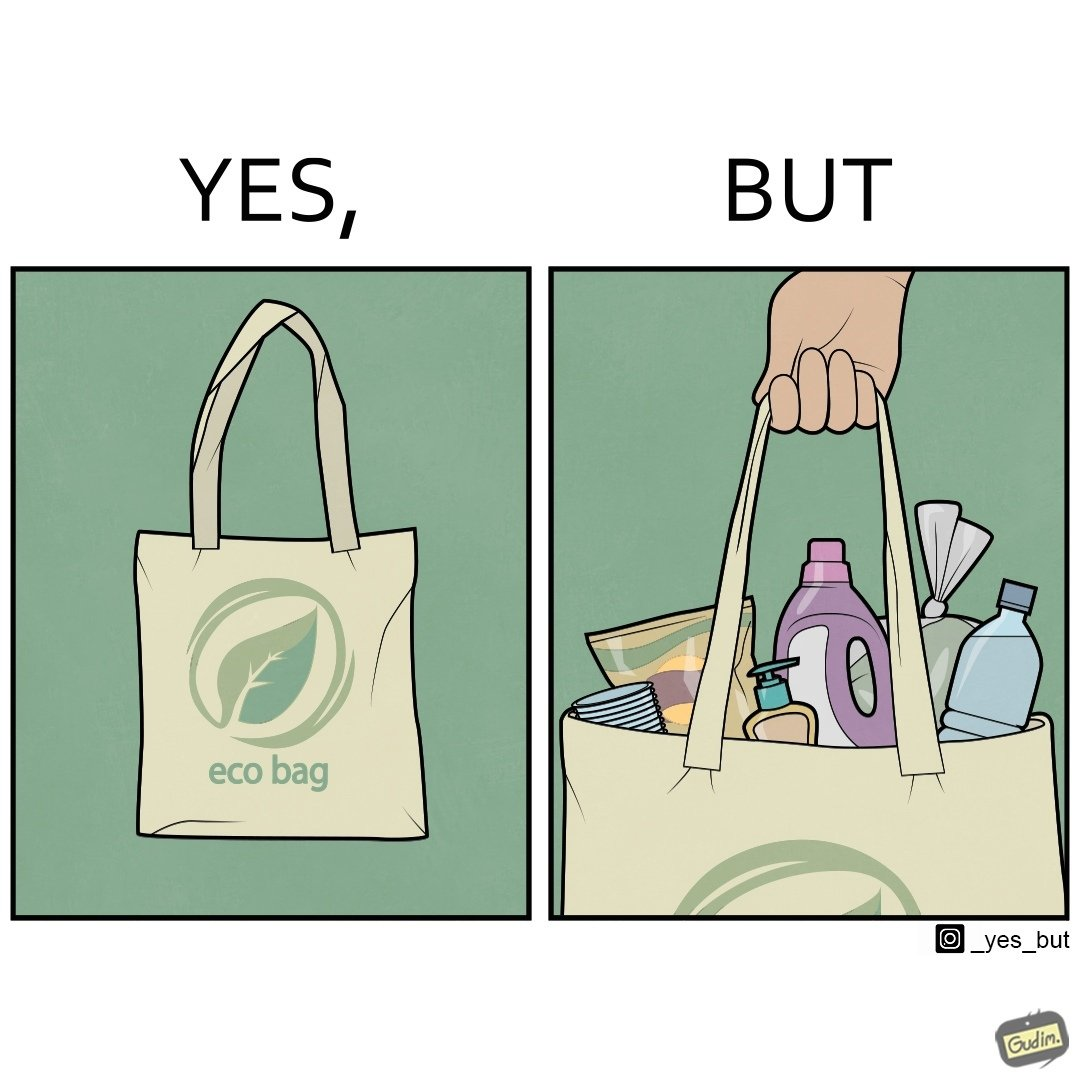Explain the humor or irony in this image. The image is ironic, because people nowadays use eco-bag thinking them as safe for the environment but in turn use products which are harmful for the environment or are packaged in some non-biodegradable material 